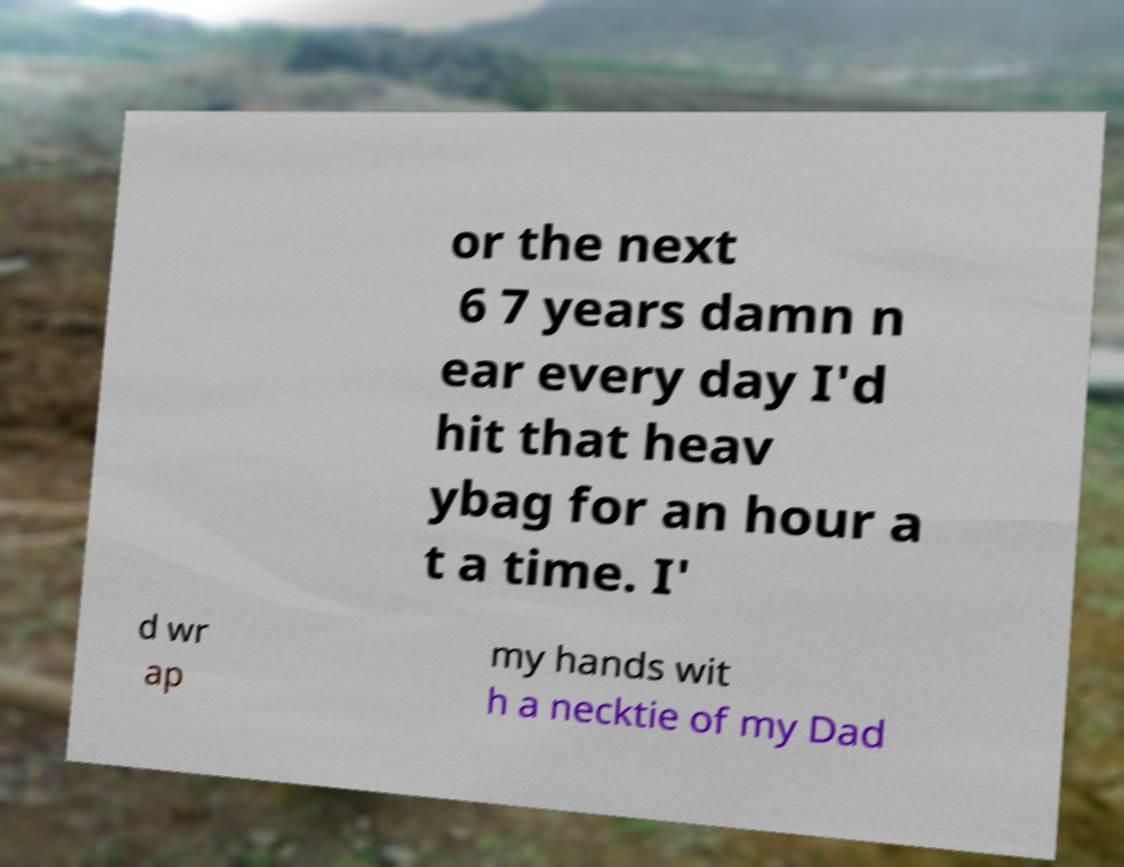Please identify and transcribe the text found in this image. or the next 6 7 years damn n ear every day I'd hit that heav ybag for an hour a t a time. I' d wr ap my hands wit h a necktie of my Dad 